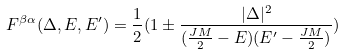Convert formula to latex. <formula><loc_0><loc_0><loc_500><loc_500>F ^ { \beta \alpha } ( \Delta , E , E ^ { \prime } ) = \frac { 1 } { 2 } ( 1 \pm \frac { | \Delta | ^ { 2 } } { ( \frac { J M } { 2 } - E ) ( E ^ { \prime } - \frac { J M } { 2 } ) } )</formula> 